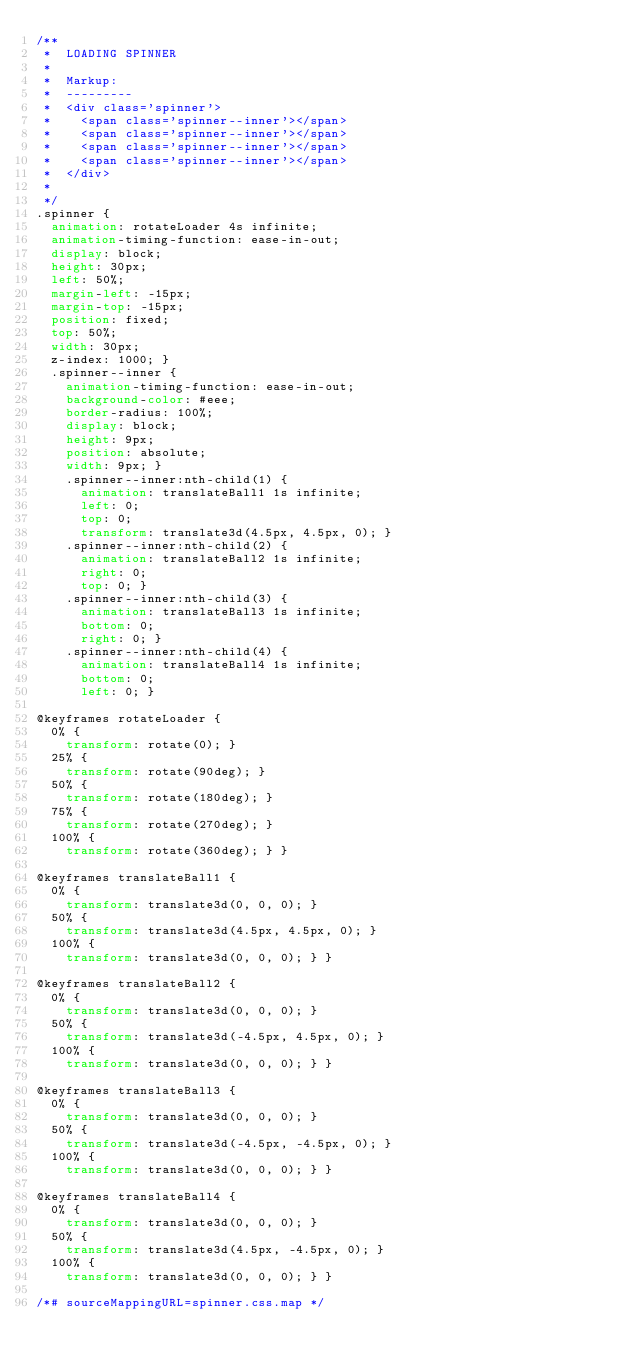<code> <loc_0><loc_0><loc_500><loc_500><_CSS_>/**
 *  LOADING SPINNER
 *
 *  Markup:
 *  ---------
 *  <div class='spinner'>
 *    <span class='spinner--inner'></span>
 *    <span class='spinner--inner'></span>
 *    <span class='spinner--inner'></span>
 *    <span class='spinner--inner'></span>
 *  </div>
 *
 */
.spinner {
  animation: rotateLoader 4s infinite;
  animation-timing-function: ease-in-out;
  display: block;
  height: 30px;
  left: 50%;
  margin-left: -15px;
  margin-top: -15px;
  position: fixed;
  top: 50%;
  width: 30px;
  z-index: 1000; }
  .spinner--inner {
    animation-timing-function: ease-in-out;
    background-color: #eee;
    border-radius: 100%;
    display: block;
    height: 9px;
    position: absolute;
    width: 9px; }
    .spinner--inner:nth-child(1) {
      animation: translateBall1 1s infinite;
      left: 0;
      top: 0;
      transform: translate3d(4.5px, 4.5px, 0); }
    .spinner--inner:nth-child(2) {
      animation: translateBall2 1s infinite;
      right: 0;
      top: 0; }
    .spinner--inner:nth-child(3) {
      animation: translateBall3 1s infinite;
      bottom: 0;
      right: 0; }
    .spinner--inner:nth-child(4) {
      animation: translateBall4 1s infinite;
      bottom: 0;
      left: 0; }

@keyframes rotateLoader {
  0% {
    transform: rotate(0); }
  25% {
    transform: rotate(90deg); }
  50% {
    transform: rotate(180deg); }
  75% {
    transform: rotate(270deg); }
  100% {
    transform: rotate(360deg); } }

@keyframes translateBall1 {
  0% {
    transform: translate3d(0, 0, 0); }
  50% {
    transform: translate3d(4.5px, 4.5px, 0); }
  100% {
    transform: translate3d(0, 0, 0); } }

@keyframes translateBall2 {
  0% {
    transform: translate3d(0, 0, 0); }
  50% {
    transform: translate3d(-4.5px, 4.5px, 0); }
  100% {
    transform: translate3d(0, 0, 0); } }

@keyframes translateBall3 {
  0% {
    transform: translate3d(0, 0, 0); }
  50% {
    transform: translate3d(-4.5px, -4.5px, 0); }
  100% {
    transform: translate3d(0, 0, 0); } }

@keyframes translateBall4 {
  0% {
    transform: translate3d(0, 0, 0); }
  50% {
    transform: translate3d(4.5px, -4.5px, 0); }
  100% {
    transform: translate3d(0, 0, 0); } }

/*# sourceMappingURL=spinner.css.map */
</code> 